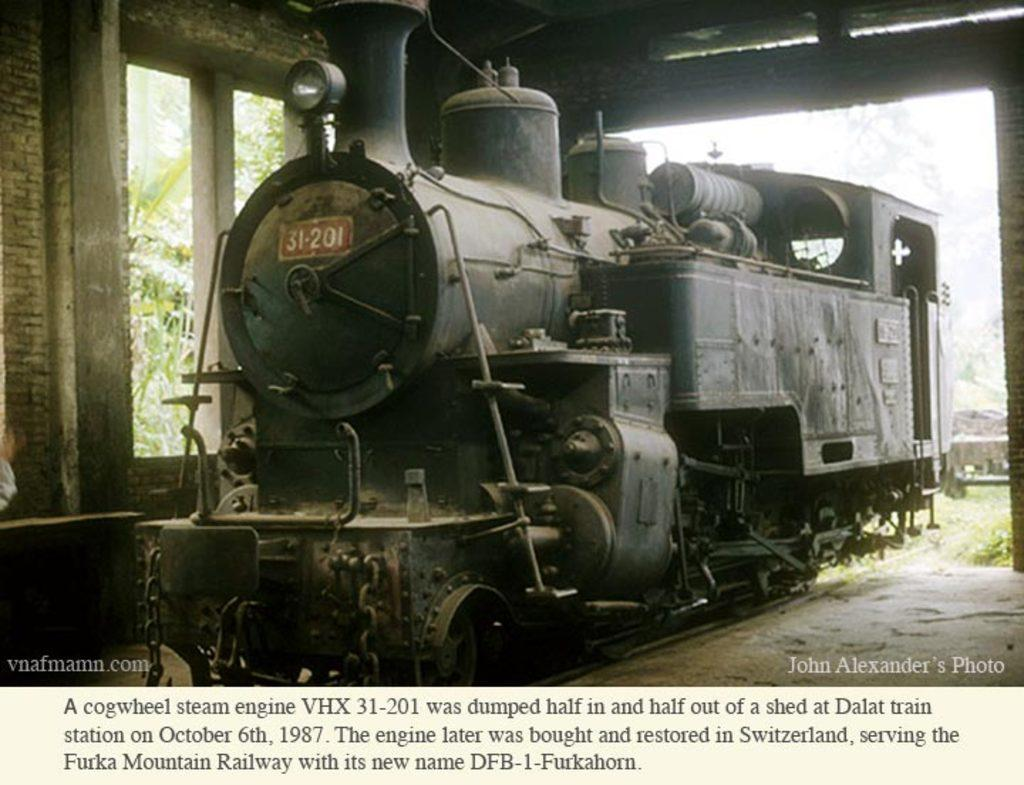What is the main subject of the image? The main subject of the image is a steam engine. How is the steam engine positioned in the image? The steam engine is placed on the ground. What can be seen in the background of the image? There is a window and trees visible in the background of the image. Is there any text present in the image? Yes, there is some text on the window or nearby surface. How does the carpenter participate in the competition depicted in the image? There is no carpenter or competition present in the image; it features a steam engine on the ground with a window and trees in the background. 